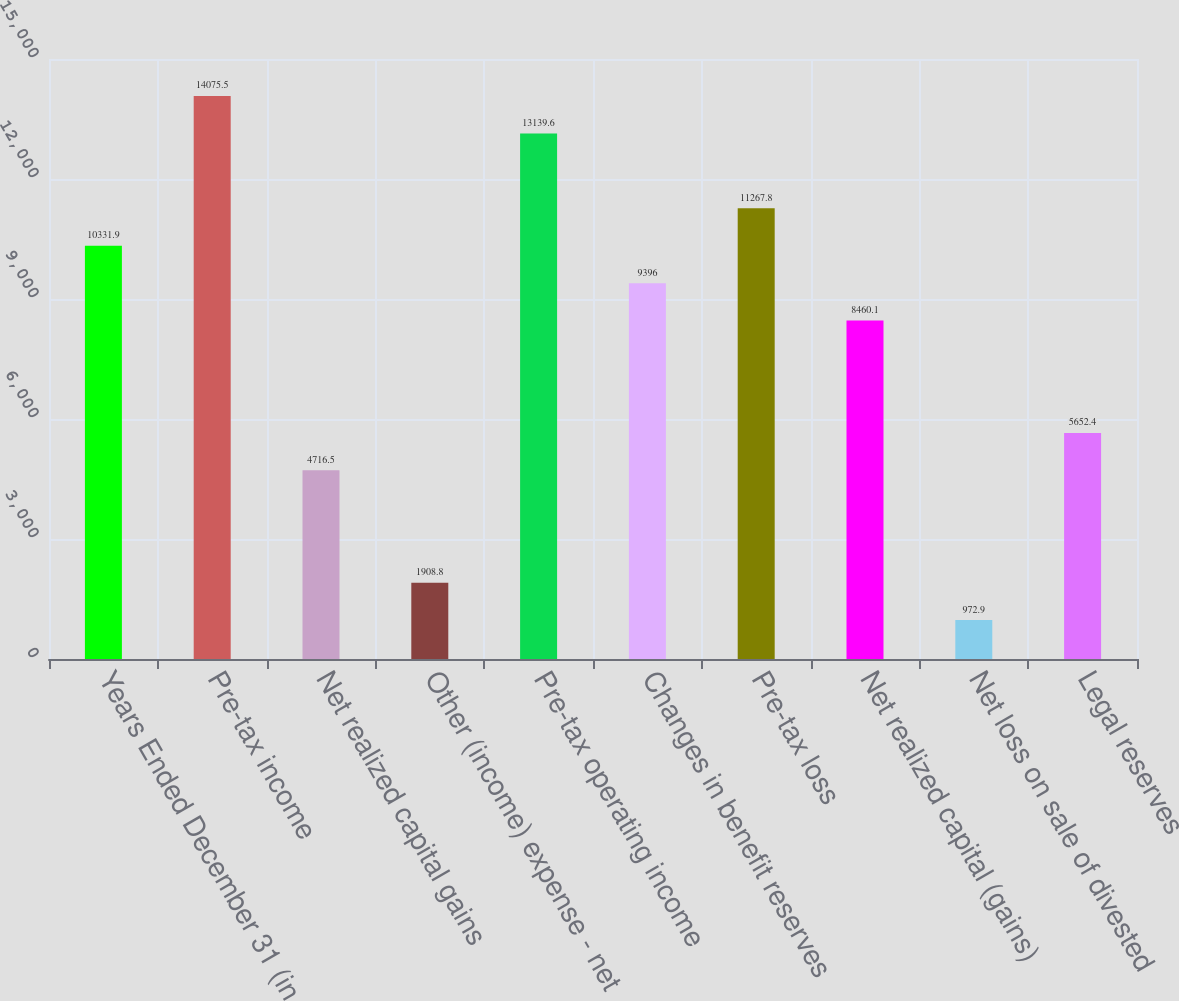Convert chart to OTSL. <chart><loc_0><loc_0><loc_500><loc_500><bar_chart><fcel>Years Ended December 31 (in<fcel>Pre-tax income<fcel>Net realized capital gains<fcel>Other (income) expense - net<fcel>Pre-tax operating income<fcel>Changes in benefit reserves<fcel>Pre-tax loss<fcel>Net realized capital (gains)<fcel>Net loss on sale of divested<fcel>Legal reserves<nl><fcel>10331.9<fcel>14075.5<fcel>4716.5<fcel>1908.8<fcel>13139.6<fcel>9396<fcel>11267.8<fcel>8460.1<fcel>972.9<fcel>5652.4<nl></chart> 